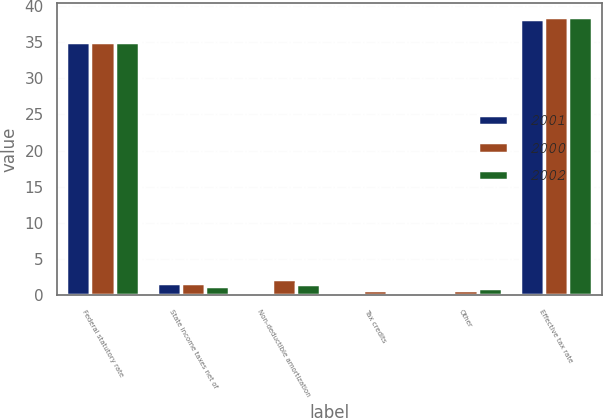Convert chart to OTSL. <chart><loc_0><loc_0><loc_500><loc_500><stacked_bar_chart><ecel><fcel>Federal statutory rate<fcel>State income taxes net of<fcel>Non-deductible amortization<fcel>Tax credits<fcel>Other<fcel>Effective tax rate<nl><fcel>2001<fcel>35<fcel>1.7<fcel>0.2<fcel>0.4<fcel>0.4<fcel>38.2<nl><fcel>2000<fcel>35<fcel>1.7<fcel>2.3<fcel>0.8<fcel>0.7<fcel>38.5<nl><fcel>2002<fcel>35<fcel>1.3<fcel>1.6<fcel>0.5<fcel>1.1<fcel>38.5<nl></chart> 